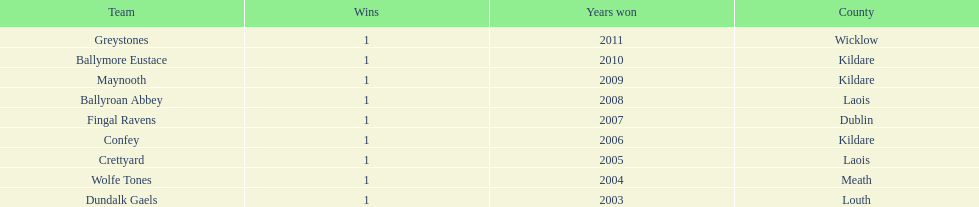What is the number of wins for confey 1. 